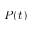<formula> <loc_0><loc_0><loc_500><loc_500>P ( t )</formula> 